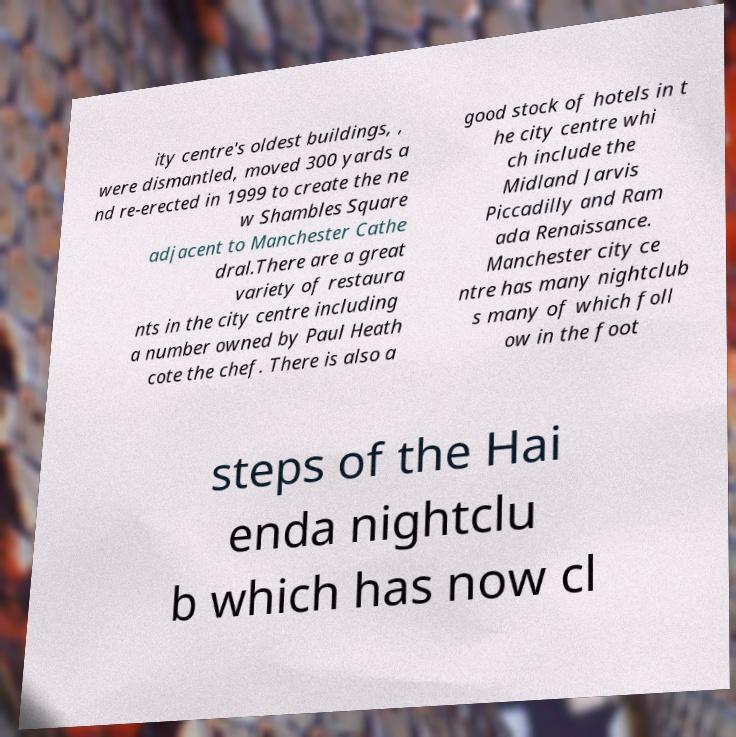Can you read and provide the text displayed in the image?This photo seems to have some interesting text. Can you extract and type it out for me? ity centre's oldest buildings, , were dismantled, moved 300 yards a nd re-erected in 1999 to create the ne w Shambles Square adjacent to Manchester Cathe dral.There are a great variety of restaura nts in the city centre including a number owned by Paul Heath cote the chef. There is also a good stock of hotels in t he city centre whi ch include the Midland Jarvis Piccadilly and Ram ada Renaissance. Manchester city ce ntre has many nightclub s many of which foll ow in the foot steps of the Hai enda nightclu b which has now cl 